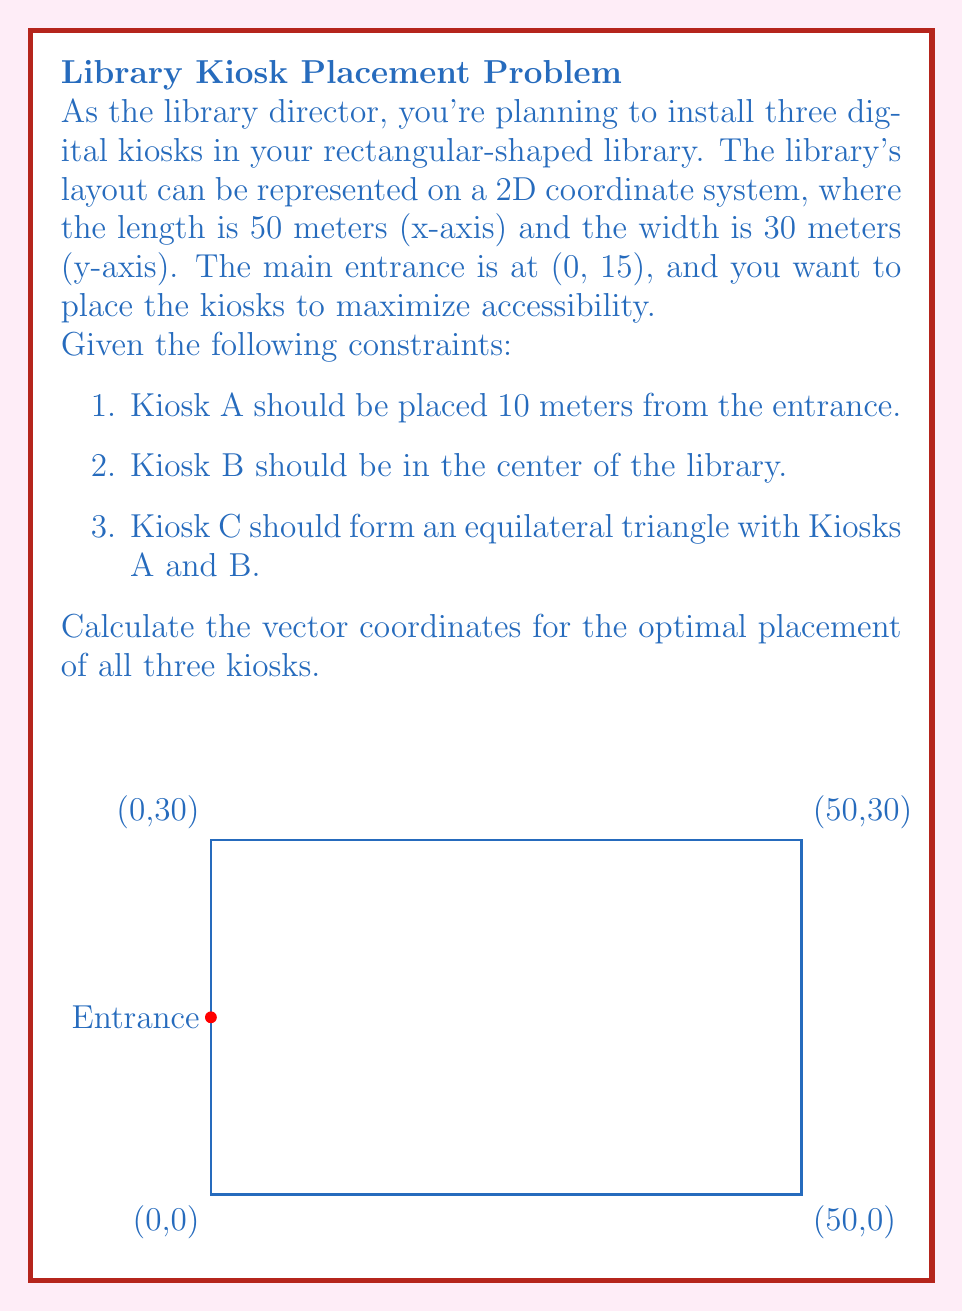Can you solve this math problem? Let's solve this problem step by step:

1. Kiosk A:
   - It should be 10 meters from the entrance (0, 15).
   - We can use the vector $\vec{v} = (10, 0)$ to represent this displacement.
   - Coordinates of Kiosk A: $(0+10, 15+0) = (10, 15)$

2. Kiosk B:
   - It should be at the center of the library.
   - Center coordinates: $(\frac{50}{2}, \frac{30}{2}) = (25, 15)$

3. Kiosk C:
   - It should form an equilateral triangle with A and B.
   - Vector from A to B: $\vec{AB} = (25-10, 15-15) = (15, 0)$
   - To form an equilateral triangle, we need to rotate this vector by 60° and scale it by $\frac{\sqrt{3}}{2}$.
   - Rotation matrix for 60°: $R = \begin{pmatrix} \cos 60° & -\sin 60° \\ \sin 60° & \cos 60° \end{pmatrix} = \begin{pmatrix} \frac{1}{2} & -\frac{\sqrt{3}}{2} \\ \frac{\sqrt{3}}{2} & \frac{1}{2} \end{pmatrix}$
   - Vector AC: $\vec{AC} = \frac{\sqrt{3}}{2} R \vec{AB} = \frac{\sqrt{3}}{2} \begin{pmatrix} \frac{1}{2} & -\frac{\sqrt{3}}{2} \\ \frac{\sqrt{3}}{2} & \frac{1}{2} \end{pmatrix} \begin{pmatrix} 15 \\ 0 \end{pmatrix} = \begin{pmatrix} \frac{15\sqrt{3}}{4} \\ \frac{45}{4} \end{pmatrix}$
   - Coordinates of Kiosk C: $(10+\frac{15\sqrt{3}}{4}, 15+\frac{45}{4}) = (10+\frac{15\sqrt{3}}{4}, \frac{105}{4})$

Therefore, the optimal placements are:
- Kiosk A: $(10, 15)$
- Kiosk B: $(25, 15)$
- Kiosk C: $(10+\frac{15\sqrt{3}}{4}, \frac{105}{4})$
Answer: A: $(10, 15)$, B: $(25, 15)$, C: $(10+\frac{15\sqrt{3}}{4}, \frac{105}{4})$ 